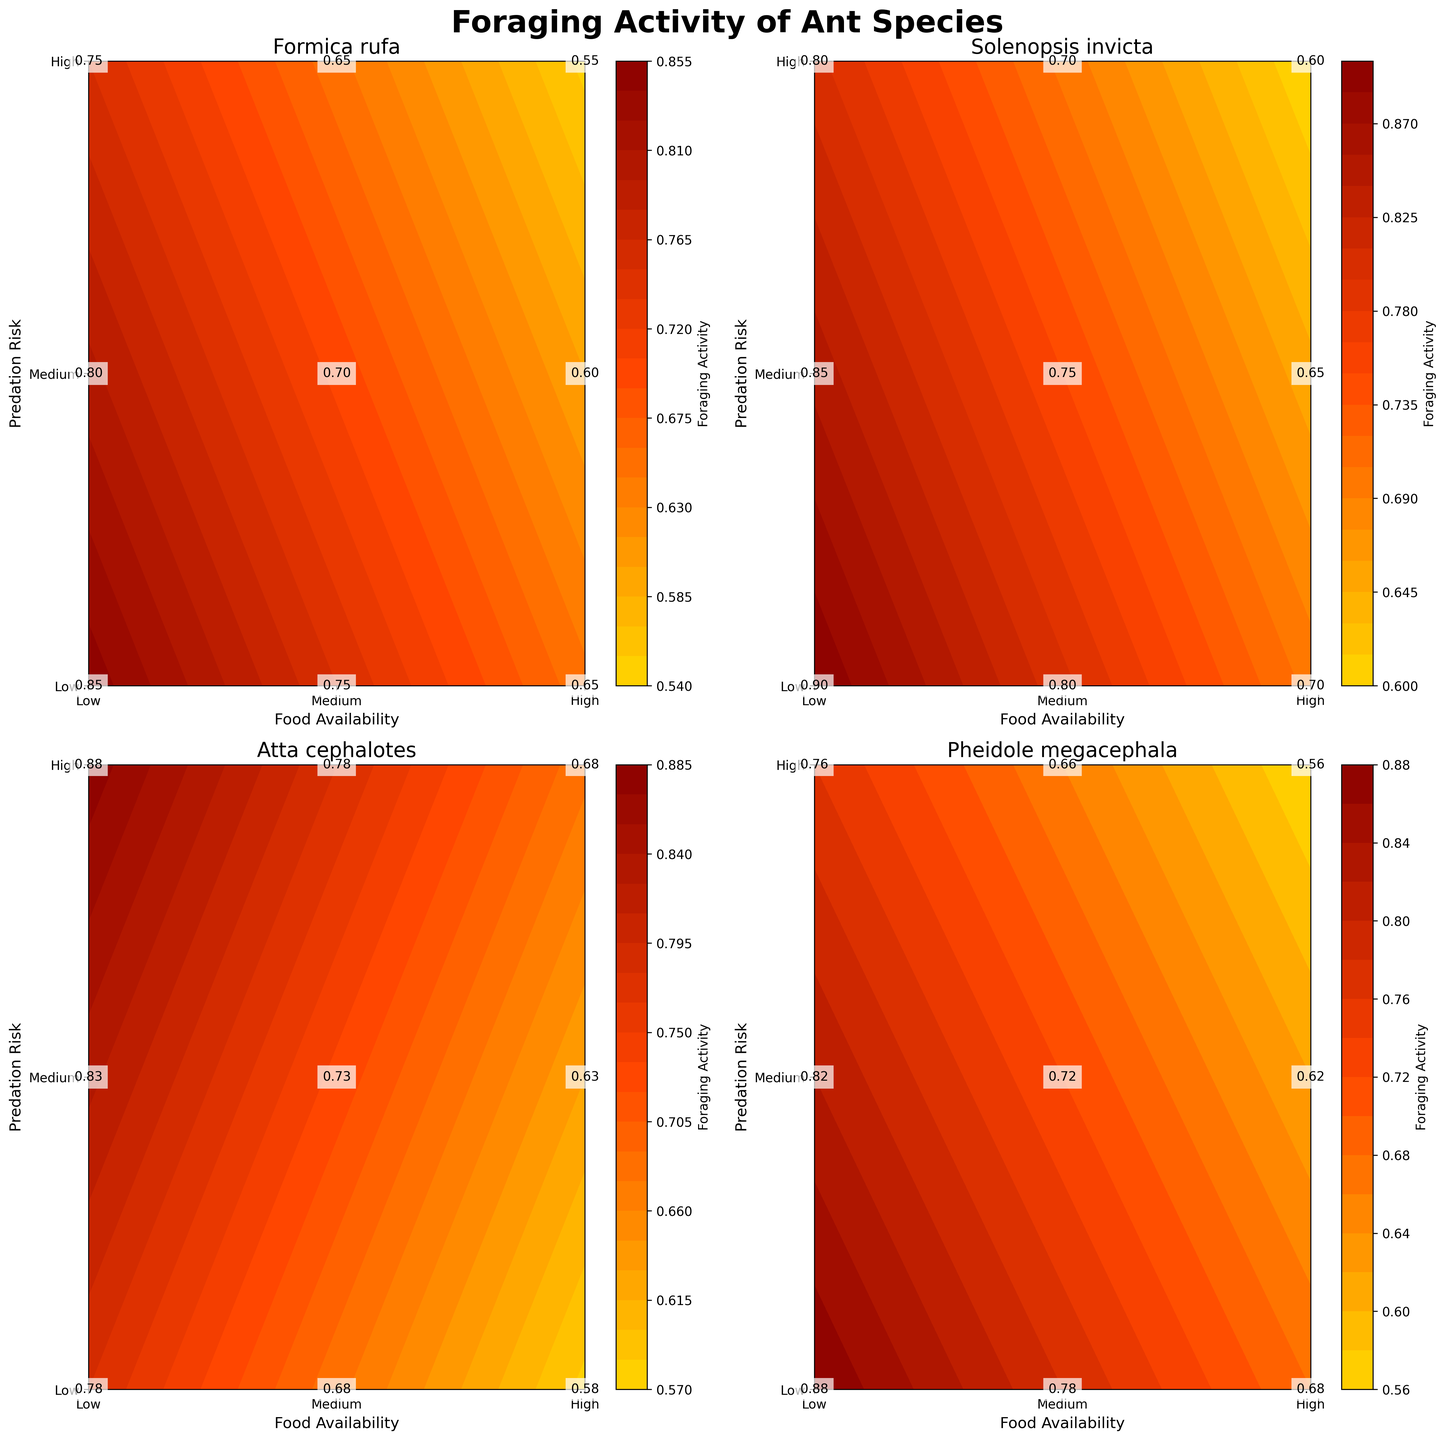What's the title of the entire plot? The title of the plot appears at the top of the figure and provides the main subject or purpose of the plot. From the given information, the title is "Foraging Activity of Ant Species".
Answer: Foraging Activity of Ant Species How many different ant species are included in the plot? The number of subplots corresponds to the number of ant species included. There are 4 subplots, each with its own title representing a different species, which are Formica rufa, Solenopsis invicta, Atta cephalotes, and Pheidole megacephala.
Answer: 4 Which ant species has the highest foraging activity when food availability is high and predation risk is low? We need to compare the values in the top-left corner of each subplot where food availability is "High" and predation risk is "Low". The species Formica rufa, Solenopsis invicta, Atta cephalotes, and Pheidole megacephala have values of 0.85, 0.90, 0.78, and 0.88 respectively.
Answer: Solenopsis invicta What is the foraging activity of Pheidole megacephala when food availability is medium and predation risk is high? Locate the value in the subplot for Pheidole megacephala at the intersection where food availability is "Medium" and predation risk is "High". The precise value is displayed in the plot.
Answer: 0.62 Which species shows the greatest difference in foraging activity between low and high predation risk when food availability is medium? First, identify the values for medium food availability with low and high predation risk in each subplot. Formica rufa: 0.80 - 0.60 = 0.20, Solenopsis invicta: 0.85 - 0.65 = 0.20, Atta cephalotes: 0.83 - 0.63 = 0.20, Pheidole megacephala: 0.82 - 0.62 = 0.20. Note that all species have the same difference of 0.20.
Answer: All species show the same difference Compare the foraging activities of Formica rufa and Atta cephalotes when food availability is low and predation risk is medium. Which species has a higher value? For Formica rufa, the value is 0.65, and for Atta cephalotes, it is 0.78 as per their respective subplots. We compare these two values.
Answer: Atta cephalotes What is the average foraging activity of Solenopsis invicta when food availability is high across all predation risk levels? Values for high food availability are: Low: 0.90, Medium: 0.80, High: 0.70. Calculate average: (0.90 + 0.80 + 0.70) / 3 = 0.80.
Answer: 0.80 Which ant species shows the least foraging activity under the combination of low food availability and high predation risk? Look at the value at the intersection of low food availability and high predation risk for all species. Formica rufa: 0.55, Solenopsis invicta: 0.60, Atta cephalotes: 0.68, Pheidole megacephala: 0.56. Compare these values.
Answer: Formica rufa Does high food availability always result in the highest foraging activity across all conditions for each species? Check if the highest value in each subplot corresponds to conditions where food availability is high. For Formica rufa (No, it's Medium-Low), Solenopsis invicta (Yes), Atta cephalotes (No, it's Low-Low), Pheidole megacephala (Yes).
Answer: No What is the range of foraging activity values observed for Atta cephalotes? Identify the minimum and maximum foraging activity values for Atta cephalotes by examining all values in its subplot. Min: 0.58 (High-High), Max: 0.88 (Low-Low). The range is 0.88 - 0.58 = 0.30.
Answer: 0.30 